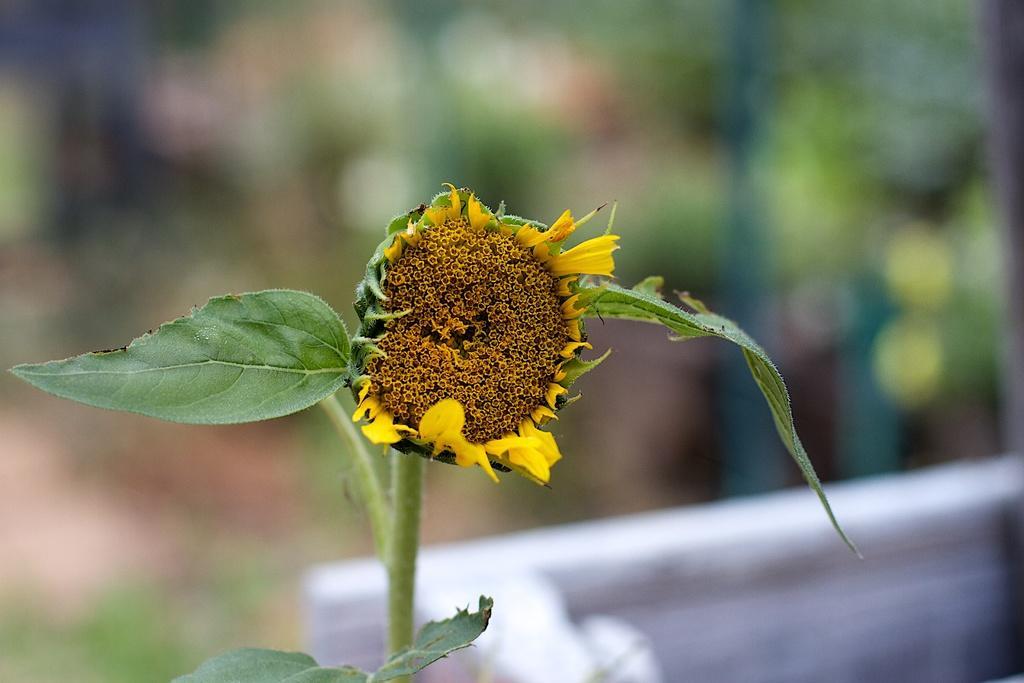Could you give a brief overview of what you see in this image? As we can see in the image there is a plant, flower and a wall. The background is blurred. 